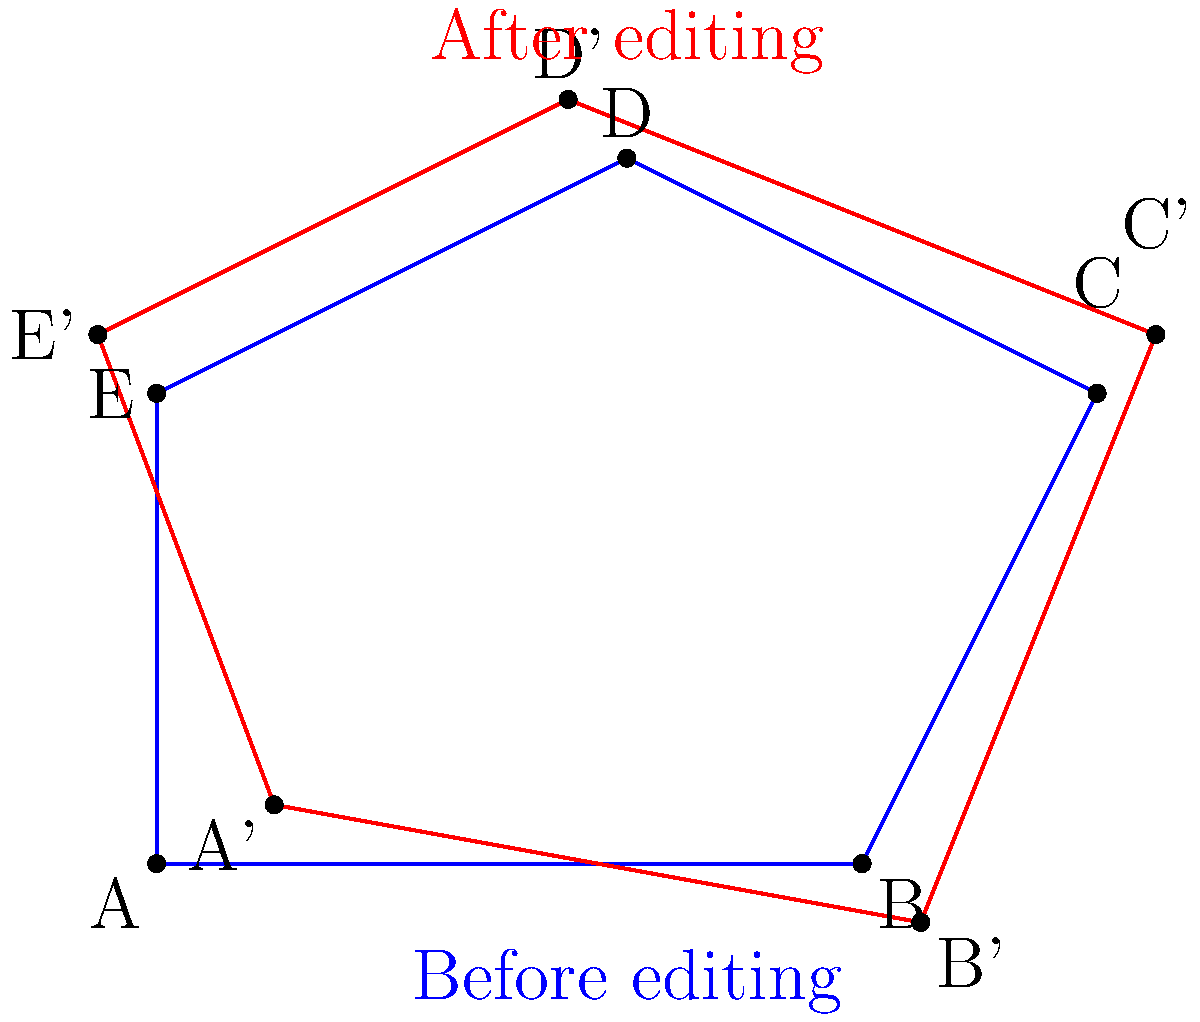A fashion photographer has taken a picture of a model striking a pose. The key points of the model's pose form a pentagon ABCDE. After editing, these points shift slightly to form a new pentagon A'B'C'D'E'. The coordinates (in feet) of the original and edited points are:

A(0,0), B(6,0), C(8,4), D(4,6), E(0,4)
A'(1,0.5), B'(6.5,-0.5), C'(8.5,4.5), D'(3.5,6.5), E'(-0.5,4.5)

Calculate the difference in area between the original and edited pentagons. Round your answer to the nearest 0.1 square feet. To solve this problem, we need to:
1. Calculate the area of the original pentagon ABCDE
2. Calculate the area of the edited pentagon A'B'C'D'E'
3. Find the difference between these areas

Step 1: Area of pentagon ABCDE
We can use the shoelace formula to calculate the area:
$$Area = \frac{1}{2}|(x_1y_2 + x_2y_3 + ... + x_ny_1) - (y_1x_2 + y_2x_3 + ... + y_nx_1)|$$

$Area_{ABCDE} = \frac{1}{2}|(0 \cdot 0 + 6 \cdot 4 + 8 \cdot 6 + 4 \cdot 4 + 0 \cdot 0) - (0 \cdot 6 + 0 \cdot 8 + 4 \cdot 4 + 6 \cdot 0 + 4 \cdot 0)|$
$= \frac{1}{2}|(24 + 48 + 16) - (0 + 0 + 16 + 0 + 0)|$
$= \frac{1}{2}|88 - 16| = \frac{1}{2} \cdot 72 = 36$ sq ft

Step 2: Area of pentagon A'B'C'D'E'
Using the same formula:

$Area_{A'B'C'D'E'} = \frac{1}{2}|(1 \cdot -0.5 + 6.5 \cdot 4.5 + 8.5 \cdot 6.5 + 3.5 \cdot 4.5 + -0.5 \cdot 0.5) - (0.5 \cdot 6.5 + -0.5 \cdot 8.5 + 4.5 \cdot 3.5 + 6.5 \cdot -0.5 + 4.5 \cdot 1)|$
$= \frac{1}{2}|(-0.5 + 29.25 + 55.25 + 15.75 - 0.25) - (3.25 - 4.25 + 15.75 - 3.25 + 4.5)|$
$= \frac{1}{2}|99.5 - 16| = \frac{1}{2} \cdot 83.5 = 41.75$ sq ft

Step 3: Difference in areas
$Difference = Area_{A'B'C'D'E'} - Area_{ABCDE}$
$= 41.75 - 36 = 5.75$ sq ft

Rounding to the nearest 0.1 sq ft: 5.8 sq ft
Answer: 5.8 sq ft 